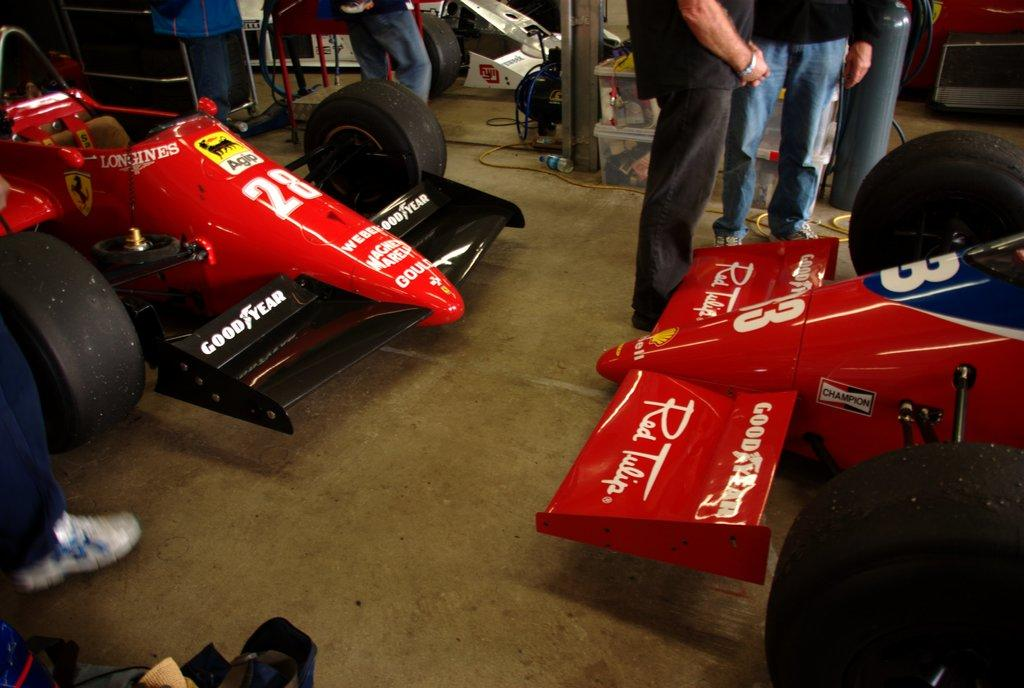What is the main subject in the center of the image? There are raising cars in the center of the image. Are there any people present in the image? Yes, there are people standing in the image. What can be seen on the floor in the image? There are objects placed on the floor in the image. What is visible in the background of the image? There is a wall visible in the background of the image. What type of cork can be seen in the image? There is no cork present in the image. How does the heat affect the raising cars in the image? The image does not provide information about the temperature or heat, so it cannot be determined how it affects the raising cars. 